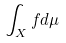Convert formula to latex. <formula><loc_0><loc_0><loc_500><loc_500>\int _ { X } f d \mu</formula> 